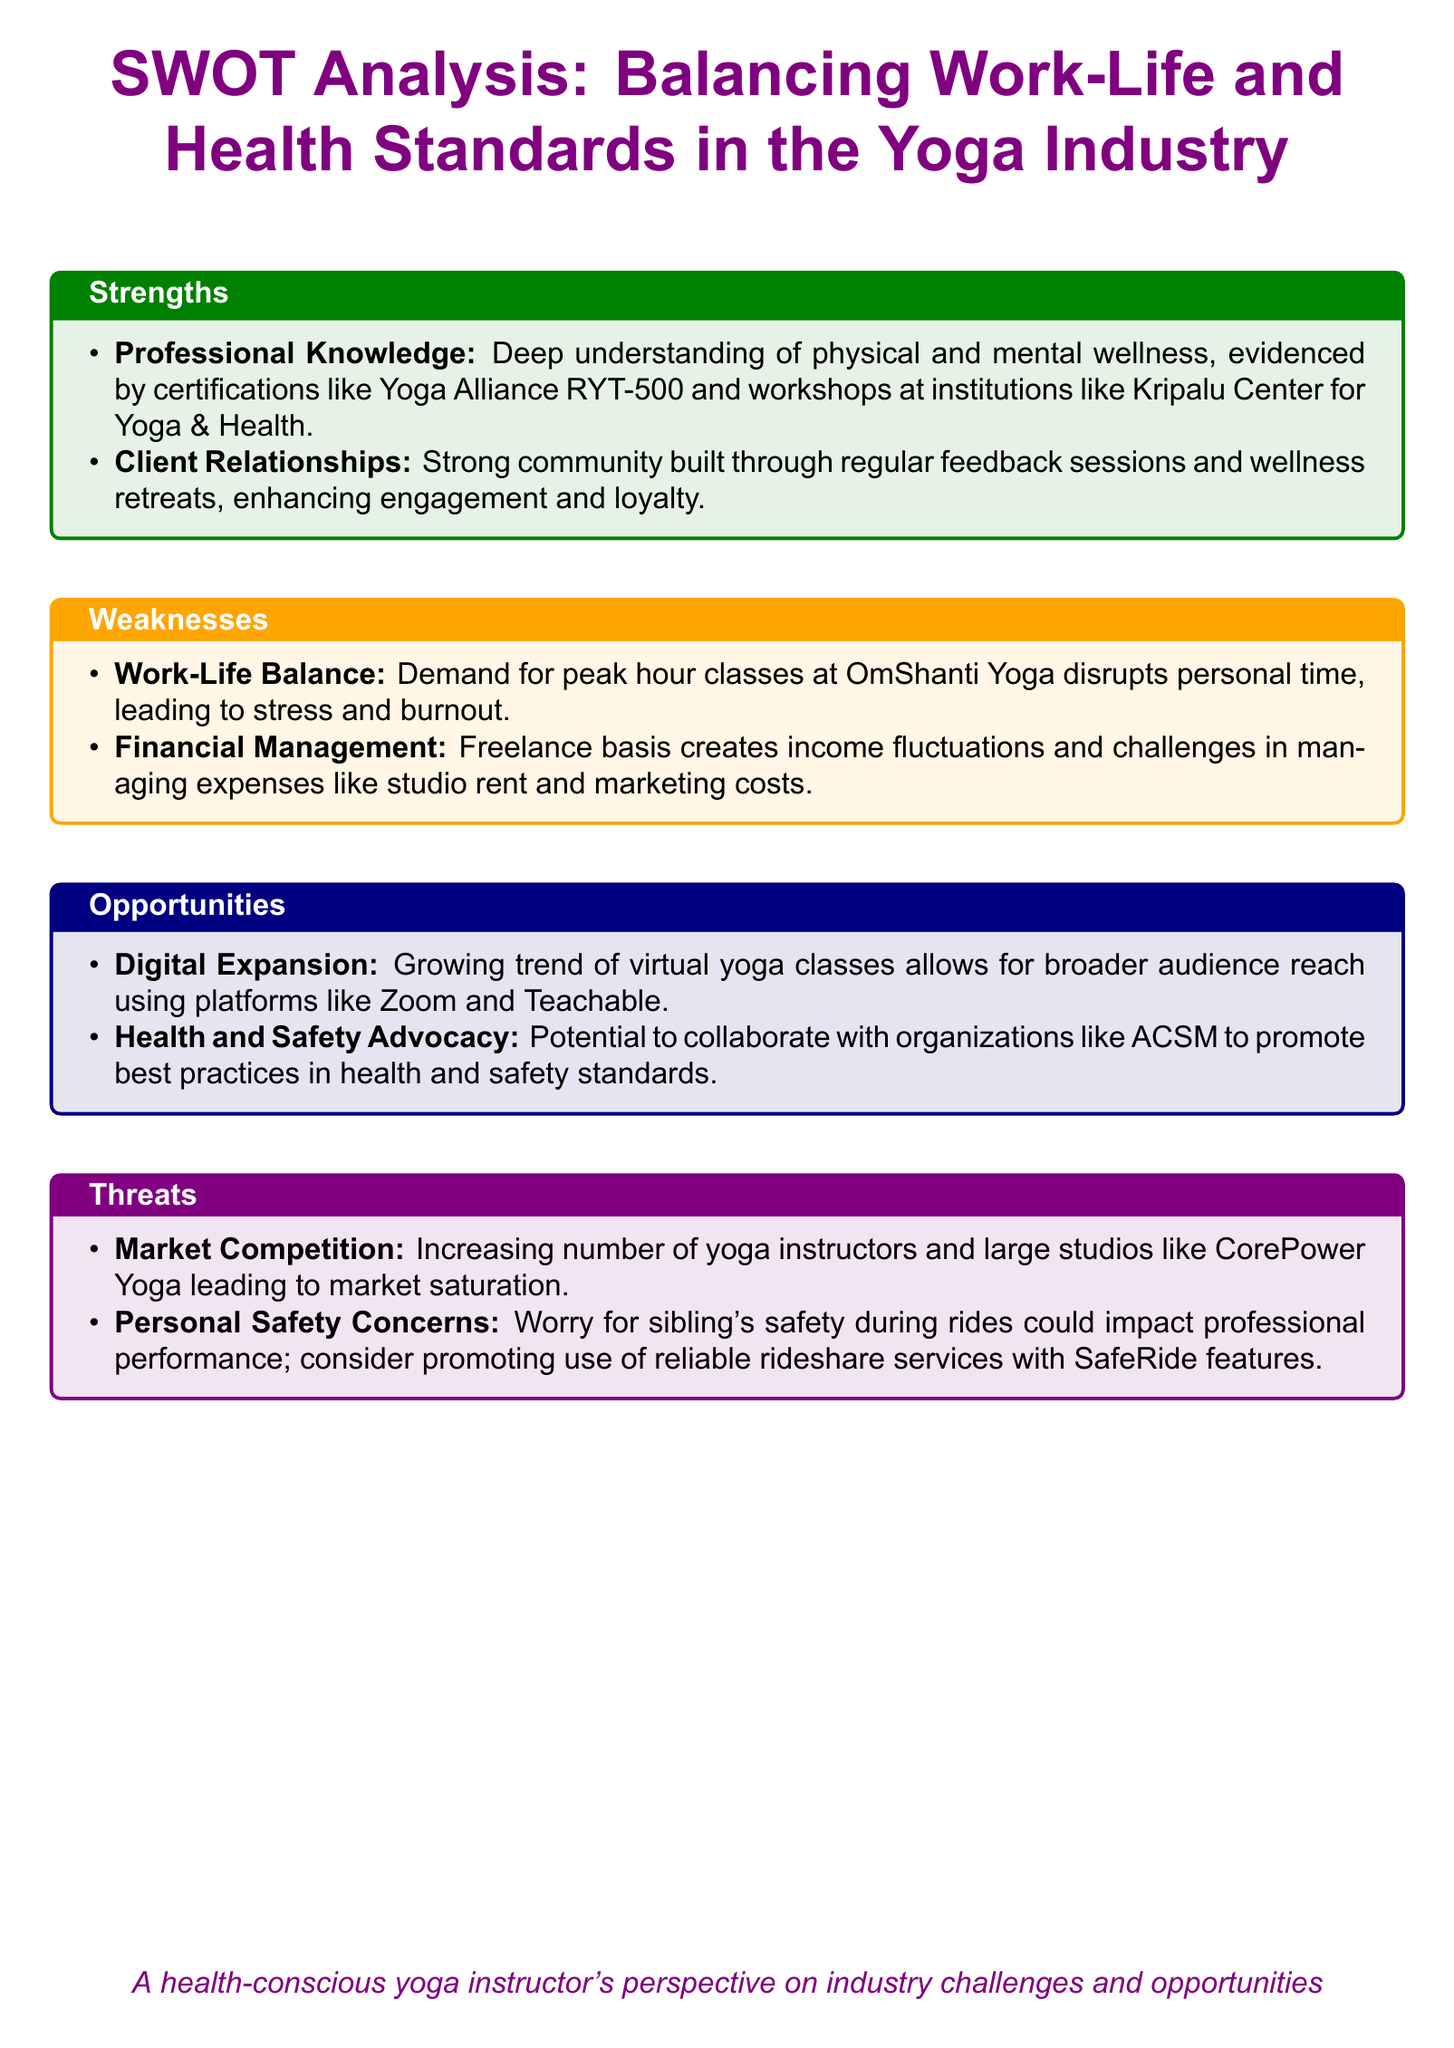What is the primary strength mentioned for yoga instructors? The primary strength is a deep understanding of physical and mental wellness, as evidenced by certifications and workshops.
Answer: Deep understanding of physical and mental wellness What is a noted weakness related to work-life balance? The weakness is described as a demand for peak hour classes disrupting personal time.
Answer: Demand for peak hour classes disrupts personal time Which opportunity involves digital platforms? This opportunity refers to the growing trend of virtual yoga classes allowing broader audience reach.
Answer: Growing trend of virtual yoga classes What organization's collaboration is mentioned for health and safety advocacy? The document mentions the possibility of collaborating with the American College of Sports Medicine (ACSM).
Answer: ACSM What is one of the threats related to competition? The threat identified is an increasing number of yoga instructors leading to market saturation.
Answer: Increasing number of yoga instructors Which personal concern is highlighted as a threat affecting professional performance? The personal concern highlighted is worry for sibling's safety during rides.
Answer: Worry for sibling's safety during rides How many strengths are listed in the SWOT analysis? The analysis lists two strengths for the yoga industry.
Answer: Two What is one financial weakness specified in the document? The specified financial weakness is related to the freelance basis creating income fluctuations.
Answer: Income fluctuations 